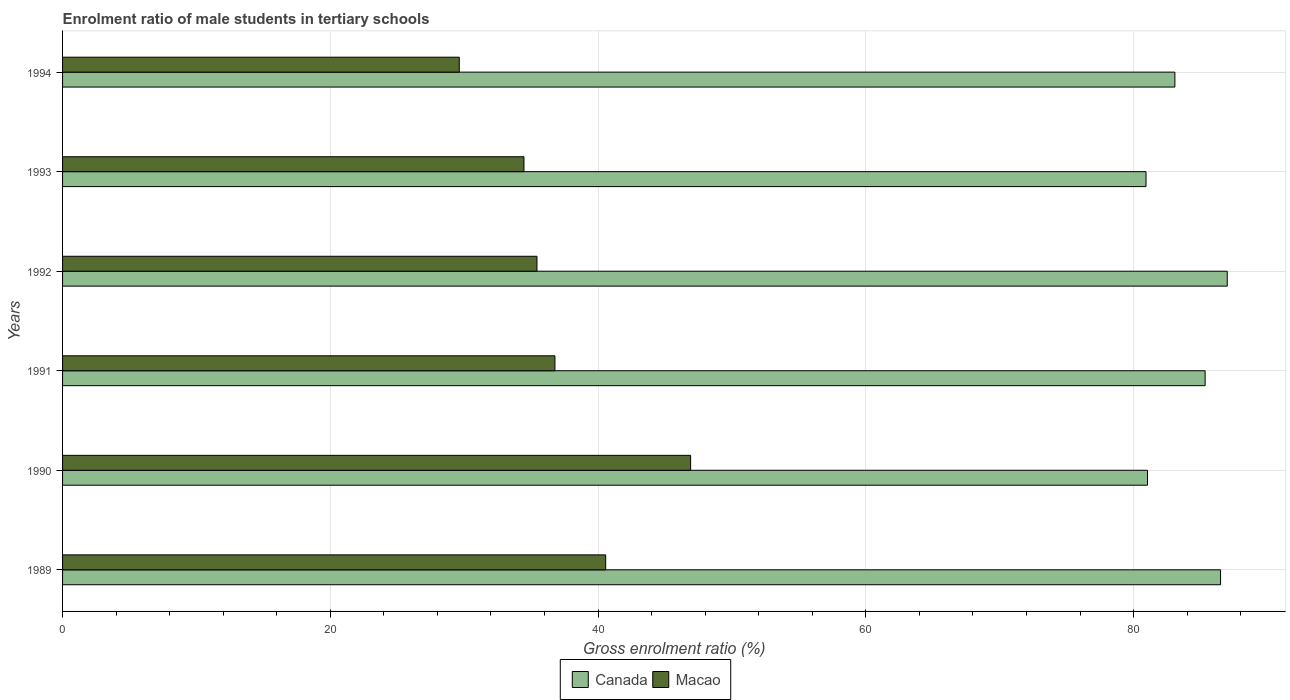How many different coloured bars are there?
Your response must be concise. 2. How many groups of bars are there?
Make the answer very short. 6. Are the number of bars per tick equal to the number of legend labels?
Offer a terse response. Yes. Are the number of bars on each tick of the Y-axis equal?
Provide a short and direct response. Yes. How many bars are there on the 2nd tick from the top?
Make the answer very short. 2. How many bars are there on the 5th tick from the bottom?
Keep it short and to the point. 2. What is the label of the 3rd group of bars from the top?
Ensure brevity in your answer.  1992. In how many cases, is the number of bars for a given year not equal to the number of legend labels?
Offer a terse response. 0. What is the enrolment ratio of male students in tertiary schools in Macao in 1989?
Your answer should be very brief. 40.57. Across all years, what is the maximum enrolment ratio of male students in tertiary schools in Macao?
Provide a short and direct response. 46.91. Across all years, what is the minimum enrolment ratio of male students in tertiary schools in Canada?
Offer a very short reply. 80.93. In which year was the enrolment ratio of male students in tertiary schools in Macao maximum?
Keep it short and to the point. 1990. What is the total enrolment ratio of male students in tertiary schools in Macao in the graph?
Offer a terse response. 223.8. What is the difference between the enrolment ratio of male students in tertiary schools in Macao in 1991 and that in 1992?
Ensure brevity in your answer.  1.34. What is the difference between the enrolment ratio of male students in tertiary schools in Canada in 1990 and the enrolment ratio of male students in tertiary schools in Macao in 1989?
Your response must be concise. 40.47. What is the average enrolment ratio of male students in tertiary schools in Macao per year?
Ensure brevity in your answer.  37.3. In the year 1993, what is the difference between the enrolment ratio of male students in tertiary schools in Macao and enrolment ratio of male students in tertiary schools in Canada?
Keep it short and to the point. -46.46. What is the ratio of the enrolment ratio of male students in tertiary schools in Canada in 1991 to that in 1993?
Make the answer very short. 1.05. What is the difference between the highest and the second highest enrolment ratio of male students in tertiary schools in Canada?
Keep it short and to the point. 0.5. What is the difference between the highest and the lowest enrolment ratio of male students in tertiary schools in Macao?
Your answer should be compact. 17.28. Is the sum of the enrolment ratio of male students in tertiary schools in Canada in 1991 and 1992 greater than the maximum enrolment ratio of male students in tertiary schools in Macao across all years?
Offer a very short reply. Yes. What does the 1st bar from the top in 1990 represents?
Your response must be concise. Macao. What does the 1st bar from the bottom in 1992 represents?
Provide a succinct answer. Canada. How many bars are there?
Ensure brevity in your answer.  12. Does the graph contain grids?
Offer a very short reply. Yes. Where does the legend appear in the graph?
Keep it short and to the point. Bottom center. What is the title of the graph?
Your response must be concise. Enrolment ratio of male students in tertiary schools. Does "Dominica" appear as one of the legend labels in the graph?
Keep it short and to the point. No. What is the Gross enrolment ratio (%) in Canada in 1989?
Make the answer very short. 86.5. What is the Gross enrolment ratio (%) in Macao in 1989?
Ensure brevity in your answer.  40.57. What is the Gross enrolment ratio (%) in Canada in 1990?
Your response must be concise. 81.04. What is the Gross enrolment ratio (%) of Macao in 1990?
Give a very brief answer. 46.91. What is the Gross enrolment ratio (%) in Canada in 1991?
Your answer should be very brief. 85.34. What is the Gross enrolment ratio (%) in Macao in 1991?
Provide a succinct answer. 36.78. What is the Gross enrolment ratio (%) of Canada in 1992?
Make the answer very short. 87. What is the Gross enrolment ratio (%) of Macao in 1992?
Keep it short and to the point. 35.44. What is the Gross enrolment ratio (%) in Canada in 1993?
Your answer should be very brief. 80.93. What is the Gross enrolment ratio (%) of Macao in 1993?
Your answer should be very brief. 34.47. What is the Gross enrolment ratio (%) in Canada in 1994?
Your answer should be very brief. 83.09. What is the Gross enrolment ratio (%) in Macao in 1994?
Make the answer very short. 29.63. Across all years, what is the maximum Gross enrolment ratio (%) of Canada?
Your answer should be very brief. 87. Across all years, what is the maximum Gross enrolment ratio (%) of Macao?
Keep it short and to the point. 46.91. Across all years, what is the minimum Gross enrolment ratio (%) in Canada?
Your response must be concise. 80.93. Across all years, what is the minimum Gross enrolment ratio (%) in Macao?
Ensure brevity in your answer.  29.63. What is the total Gross enrolment ratio (%) of Canada in the graph?
Give a very brief answer. 503.9. What is the total Gross enrolment ratio (%) in Macao in the graph?
Provide a short and direct response. 223.8. What is the difference between the Gross enrolment ratio (%) in Canada in 1989 and that in 1990?
Keep it short and to the point. 5.46. What is the difference between the Gross enrolment ratio (%) in Macao in 1989 and that in 1990?
Your answer should be very brief. -6.35. What is the difference between the Gross enrolment ratio (%) of Canada in 1989 and that in 1991?
Your response must be concise. 1.15. What is the difference between the Gross enrolment ratio (%) of Macao in 1989 and that in 1991?
Offer a terse response. 3.79. What is the difference between the Gross enrolment ratio (%) in Canada in 1989 and that in 1992?
Provide a succinct answer. -0.5. What is the difference between the Gross enrolment ratio (%) of Macao in 1989 and that in 1992?
Give a very brief answer. 5.13. What is the difference between the Gross enrolment ratio (%) of Canada in 1989 and that in 1993?
Offer a very short reply. 5.57. What is the difference between the Gross enrolment ratio (%) of Macao in 1989 and that in 1993?
Keep it short and to the point. 6.1. What is the difference between the Gross enrolment ratio (%) of Canada in 1989 and that in 1994?
Give a very brief answer. 3.41. What is the difference between the Gross enrolment ratio (%) in Macao in 1989 and that in 1994?
Offer a very short reply. 10.94. What is the difference between the Gross enrolment ratio (%) of Canada in 1990 and that in 1991?
Offer a terse response. -4.3. What is the difference between the Gross enrolment ratio (%) of Macao in 1990 and that in 1991?
Your answer should be very brief. 10.14. What is the difference between the Gross enrolment ratio (%) in Canada in 1990 and that in 1992?
Give a very brief answer. -5.96. What is the difference between the Gross enrolment ratio (%) of Macao in 1990 and that in 1992?
Your answer should be compact. 11.48. What is the difference between the Gross enrolment ratio (%) in Canada in 1990 and that in 1993?
Provide a short and direct response. 0.11. What is the difference between the Gross enrolment ratio (%) of Macao in 1990 and that in 1993?
Ensure brevity in your answer.  12.45. What is the difference between the Gross enrolment ratio (%) of Canada in 1990 and that in 1994?
Ensure brevity in your answer.  -2.05. What is the difference between the Gross enrolment ratio (%) in Macao in 1990 and that in 1994?
Give a very brief answer. 17.28. What is the difference between the Gross enrolment ratio (%) in Canada in 1991 and that in 1992?
Your answer should be compact. -1.65. What is the difference between the Gross enrolment ratio (%) of Macao in 1991 and that in 1992?
Give a very brief answer. 1.34. What is the difference between the Gross enrolment ratio (%) in Canada in 1991 and that in 1993?
Your response must be concise. 4.41. What is the difference between the Gross enrolment ratio (%) in Macao in 1991 and that in 1993?
Give a very brief answer. 2.31. What is the difference between the Gross enrolment ratio (%) of Canada in 1991 and that in 1994?
Give a very brief answer. 2.26. What is the difference between the Gross enrolment ratio (%) in Macao in 1991 and that in 1994?
Provide a short and direct response. 7.14. What is the difference between the Gross enrolment ratio (%) of Canada in 1992 and that in 1993?
Give a very brief answer. 6.07. What is the difference between the Gross enrolment ratio (%) in Macao in 1992 and that in 1993?
Ensure brevity in your answer.  0.97. What is the difference between the Gross enrolment ratio (%) in Canada in 1992 and that in 1994?
Your answer should be very brief. 3.91. What is the difference between the Gross enrolment ratio (%) in Macao in 1992 and that in 1994?
Keep it short and to the point. 5.8. What is the difference between the Gross enrolment ratio (%) of Canada in 1993 and that in 1994?
Your response must be concise. -2.16. What is the difference between the Gross enrolment ratio (%) in Macao in 1993 and that in 1994?
Provide a short and direct response. 4.83. What is the difference between the Gross enrolment ratio (%) in Canada in 1989 and the Gross enrolment ratio (%) in Macao in 1990?
Provide a succinct answer. 39.58. What is the difference between the Gross enrolment ratio (%) in Canada in 1989 and the Gross enrolment ratio (%) in Macao in 1991?
Your response must be concise. 49.72. What is the difference between the Gross enrolment ratio (%) in Canada in 1989 and the Gross enrolment ratio (%) in Macao in 1992?
Your answer should be compact. 51.06. What is the difference between the Gross enrolment ratio (%) of Canada in 1989 and the Gross enrolment ratio (%) of Macao in 1993?
Offer a very short reply. 52.03. What is the difference between the Gross enrolment ratio (%) of Canada in 1989 and the Gross enrolment ratio (%) of Macao in 1994?
Your answer should be very brief. 56.86. What is the difference between the Gross enrolment ratio (%) of Canada in 1990 and the Gross enrolment ratio (%) of Macao in 1991?
Make the answer very short. 44.26. What is the difference between the Gross enrolment ratio (%) of Canada in 1990 and the Gross enrolment ratio (%) of Macao in 1992?
Offer a terse response. 45.61. What is the difference between the Gross enrolment ratio (%) of Canada in 1990 and the Gross enrolment ratio (%) of Macao in 1993?
Offer a terse response. 46.58. What is the difference between the Gross enrolment ratio (%) of Canada in 1990 and the Gross enrolment ratio (%) of Macao in 1994?
Make the answer very short. 51.41. What is the difference between the Gross enrolment ratio (%) of Canada in 1991 and the Gross enrolment ratio (%) of Macao in 1992?
Provide a short and direct response. 49.91. What is the difference between the Gross enrolment ratio (%) in Canada in 1991 and the Gross enrolment ratio (%) in Macao in 1993?
Offer a terse response. 50.88. What is the difference between the Gross enrolment ratio (%) in Canada in 1991 and the Gross enrolment ratio (%) in Macao in 1994?
Keep it short and to the point. 55.71. What is the difference between the Gross enrolment ratio (%) of Canada in 1992 and the Gross enrolment ratio (%) of Macao in 1993?
Your answer should be compact. 52.53. What is the difference between the Gross enrolment ratio (%) in Canada in 1992 and the Gross enrolment ratio (%) in Macao in 1994?
Offer a very short reply. 57.36. What is the difference between the Gross enrolment ratio (%) in Canada in 1993 and the Gross enrolment ratio (%) in Macao in 1994?
Provide a short and direct response. 51.3. What is the average Gross enrolment ratio (%) of Canada per year?
Your response must be concise. 83.98. What is the average Gross enrolment ratio (%) of Macao per year?
Offer a very short reply. 37.3. In the year 1989, what is the difference between the Gross enrolment ratio (%) of Canada and Gross enrolment ratio (%) of Macao?
Your answer should be compact. 45.93. In the year 1990, what is the difference between the Gross enrolment ratio (%) of Canada and Gross enrolment ratio (%) of Macao?
Offer a very short reply. 34.13. In the year 1991, what is the difference between the Gross enrolment ratio (%) of Canada and Gross enrolment ratio (%) of Macao?
Offer a terse response. 48.57. In the year 1992, what is the difference between the Gross enrolment ratio (%) of Canada and Gross enrolment ratio (%) of Macao?
Keep it short and to the point. 51.56. In the year 1993, what is the difference between the Gross enrolment ratio (%) of Canada and Gross enrolment ratio (%) of Macao?
Give a very brief answer. 46.46. In the year 1994, what is the difference between the Gross enrolment ratio (%) of Canada and Gross enrolment ratio (%) of Macao?
Ensure brevity in your answer.  53.45. What is the ratio of the Gross enrolment ratio (%) in Canada in 1989 to that in 1990?
Your answer should be compact. 1.07. What is the ratio of the Gross enrolment ratio (%) of Macao in 1989 to that in 1990?
Your answer should be compact. 0.86. What is the ratio of the Gross enrolment ratio (%) in Canada in 1989 to that in 1991?
Offer a terse response. 1.01. What is the ratio of the Gross enrolment ratio (%) of Macao in 1989 to that in 1991?
Give a very brief answer. 1.1. What is the ratio of the Gross enrolment ratio (%) of Canada in 1989 to that in 1992?
Your answer should be very brief. 0.99. What is the ratio of the Gross enrolment ratio (%) in Macao in 1989 to that in 1992?
Keep it short and to the point. 1.14. What is the ratio of the Gross enrolment ratio (%) of Canada in 1989 to that in 1993?
Offer a very short reply. 1.07. What is the ratio of the Gross enrolment ratio (%) in Macao in 1989 to that in 1993?
Offer a terse response. 1.18. What is the ratio of the Gross enrolment ratio (%) of Canada in 1989 to that in 1994?
Your response must be concise. 1.04. What is the ratio of the Gross enrolment ratio (%) of Macao in 1989 to that in 1994?
Make the answer very short. 1.37. What is the ratio of the Gross enrolment ratio (%) in Canada in 1990 to that in 1991?
Your answer should be compact. 0.95. What is the ratio of the Gross enrolment ratio (%) of Macao in 1990 to that in 1991?
Provide a short and direct response. 1.28. What is the ratio of the Gross enrolment ratio (%) of Canada in 1990 to that in 1992?
Offer a very short reply. 0.93. What is the ratio of the Gross enrolment ratio (%) in Macao in 1990 to that in 1992?
Your answer should be very brief. 1.32. What is the ratio of the Gross enrolment ratio (%) of Canada in 1990 to that in 1993?
Provide a short and direct response. 1. What is the ratio of the Gross enrolment ratio (%) of Macao in 1990 to that in 1993?
Your response must be concise. 1.36. What is the ratio of the Gross enrolment ratio (%) of Canada in 1990 to that in 1994?
Offer a very short reply. 0.98. What is the ratio of the Gross enrolment ratio (%) in Macao in 1990 to that in 1994?
Provide a succinct answer. 1.58. What is the ratio of the Gross enrolment ratio (%) in Macao in 1991 to that in 1992?
Your answer should be very brief. 1.04. What is the ratio of the Gross enrolment ratio (%) of Canada in 1991 to that in 1993?
Your answer should be compact. 1.05. What is the ratio of the Gross enrolment ratio (%) of Macao in 1991 to that in 1993?
Provide a short and direct response. 1.07. What is the ratio of the Gross enrolment ratio (%) in Canada in 1991 to that in 1994?
Your answer should be compact. 1.03. What is the ratio of the Gross enrolment ratio (%) in Macao in 1991 to that in 1994?
Your answer should be very brief. 1.24. What is the ratio of the Gross enrolment ratio (%) in Canada in 1992 to that in 1993?
Offer a very short reply. 1.07. What is the ratio of the Gross enrolment ratio (%) of Macao in 1992 to that in 1993?
Keep it short and to the point. 1.03. What is the ratio of the Gross enrolment ratio (%) in Canada in 1992 to that in 1994?
Provide a short and direct response. 1.05. What is the ratio of the Gross enrolment ratio (%) in Macao in 1992 to that in 1994?
Your response must be concise. 1.2. What is the ratio of the Gross enrolment ratio (%) of Macao in 1993 to that in 1994?
Provide a succinct answer. 1.16. What is the difference between the highest and the second highest Gross enrolment ratio (%) of Canada?
Provide a succinct answer. 0.5. What is the difference between the highest and the second highest Gross enrolment ratio (%) in Macao?
Give a very brief answer. 6.35. What is the difference between the highest and the lowest Gross enrolment ratio (%) of Canada?
Your response must be concise. 6.07. What is the difference between the highest and the lowest Gross enrolment ratio (%) of Macao?
Make the answer very short. 17.28. 